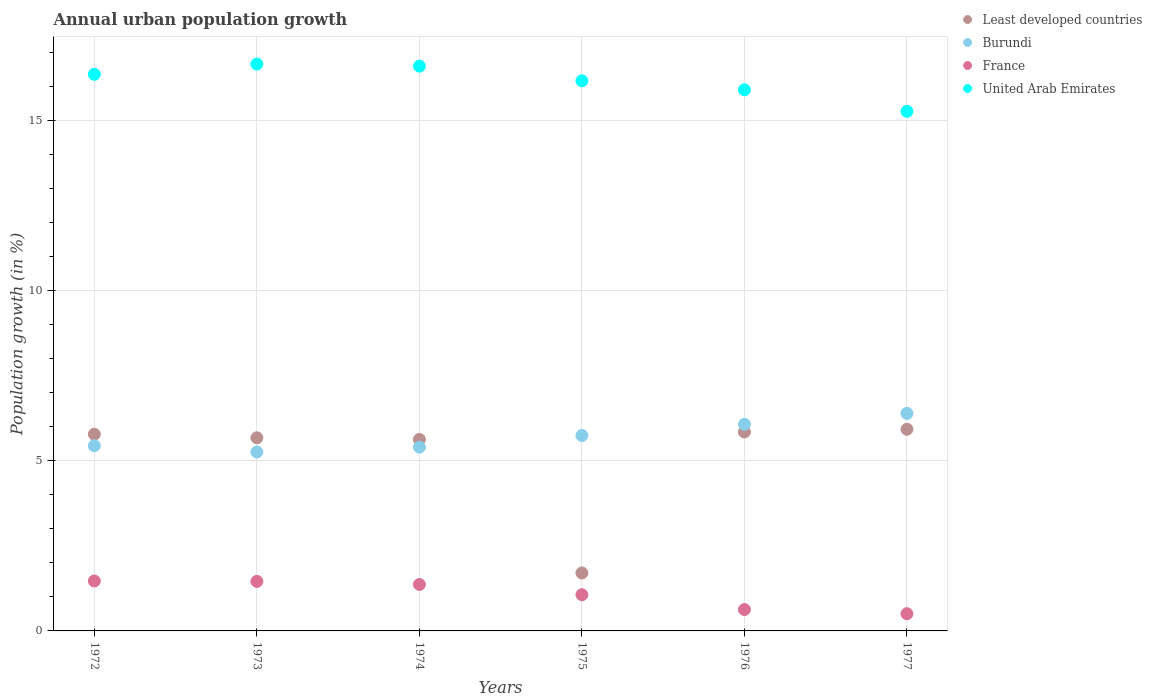What is the percentage of urban population growth in France in 1976?
Offer a very short reply. 0.63. Across all years, what is the maximum percentage of urban population growth in Least developed countries?
Provide a short and direct response. 5.93. Across all years, what is the minimum percentage of urban population growth in United Arab Emirates?
Provide a succinct answer. 15.27. What is the total percentage of urban population growth in United Arab Emirates in the graph?
Offer a very short reply. 96.97. What is the difference between the percentage of urban population growth in United Arab Emirates in 1972 and that in 1974?
Keep it short and to the point. -0.24. What is the difference between the percentage of urban population growth in France in 1975 and the percentage of urban population growth in United Arab Emirates in 1974?
Provide a succinct answer. -15.54. What is the average percentage of urban population growth in Least developed countries per year?
Your answer should be compact. 5.09. In the year 1974, what is the difference between the percentage of urban population growth in Burundi and percentage of urban population growth in France?
Keep it short and to the point. 4.03. In how many years, is the percentage of urban population growth in Least developed countries greater than 10 %?
Ensure brevity in your answer.  0. What is the ratio of the percentage of urban population growth in France in 1973 to that in 1974?
Your answer should be very brief. 1.07. What is the difference between the highest and the second highest percentage of urban population growth in United Arab Emirates?
Keep it short and to the point. 0.06. What is the difference between the highest and the lowest percentage of urban population growth in United Arab Emirates?
Ensure brevity in your answer.  1.39. Is the sum of the percentage of urban population growth in Burundi in 1972 and 1975 greater than the maximum percentage of urban population growth in United Arab Emirates across all years?
Your answer should be very brief. No. Is it the case that in every year, the sum of the percentage of urban population growth in United Arab Emirates and percentage of urban population growth in Burundi  is greater than the sum of percentage of urban population growth in Least developed countries and percentage of urban population growth in France?
Offer a very short reply. Yes. Does the percentage of urban population growth in United Arab Emirates monotonically increase over the years?
Ensure brevity in your answer.  No. Is the percentage of urban population growth in Burundi strictly less than the percentage of urban population growth in United Arab Emirates over the years?
Your answer should be compact. Yes. What is the difference between two consecutive major ticks on the Y-axis?
Make the answer very short. 5. Are the values on the major ticks of Y-axis written in scientific E-notation?
Your answer should be compact. No. Does the graph contain grids?
Ensure brevity in your answer.  Yes. Where does the legend appear in the graph?
Your answer should be compact. Top right. How many legend labels are there?
Offer a very short reply. 4. How are the legend labels stacked?
Make the answer very short. Vertical. What is the title of the graph?
Make the answer very short. Annual urban population growth. What is the label or title of the Y-axis?
Provide a succinct answer. Population growth (in %). What is the Population growth (in %) of Least developed countries in 1972?
Your answer should be compact. 5.78. What is the Population growth (in %) in Burundi in 1972?
Provide a short and direct response. 5.44. What is the Population growth (in %) of France in 1972?
Offer a very short reply. 1.47. What is the Population growth (in %) in United Arab Emirates in 1972?
Your answer should be compact. 16.36. What is the Population growth (in %) in Least developed countries in 1973?
Your answer should be compact. 5.68. What is the Population growth (in %) of Burundi in 1973?
Offer a very short reply. 5.26. What is the Population growth (in %) in France in 1973?
Offer a very short reply. 1.46. What is the Population growth (in %) in United Arab Emirates in 1973?
Your response must be concise. 16.66. What is the Population growth (in %) of Least developed countries in 1974?
Offer a very short reply. 5.63. What is the Population growth (in %) in Burundi in 1974?
Offer a very short reply. 5.4. What is the Population growth (in %) in France in 1974?
Provide a short and direct response. 1.37. What is the Population growth (in %) of United Arab Emirates in 1974?
Your response must be concise. 16.6. What is the Population growth (in %) in Least developed countries in 1975?
Keep it short and to the point. 1.7. What is the Population growth (in %) of Burundi in 1975?
Offer a very short reply. 5.74. What is the Population growth (in %) in France in 1975?
Provide a short and direct response. 1.06. What is the Population growth (in %) of United Arab Emirates in 1975?
Make the answer very short. 16.17. What is the Population growth (in %) of Least developed countries in 1976?
Make the answer very short. 5.85. What is the Population growth (in %) in Burundi in 1976?
Your answer should be compact. 6.07. What is the Population growth (in %) in France in 1976?
Your answer should be very brief. 0.63. What is the Population growth (in %) of United Arab Emirates in 1976?
Offer a very short reply. 15.91. What is the Population growth (in %) of Least developed countries in 1977?
Give a very brief answer. 5.93. What is the Population growth (in %) in Burundi in 1977?
Keep it short and to the point. 6.39. What is the Population growth (in %) in France in 1977?
Your answer should be compact. 0.51. What is the Population growth (in %) in United Arab Emirates in 1977?
Your response must be concise. 15.27. Across all years, what is the maximum Population growth (in %) in Least developed countries?
Make the answer very short. 5.93. Across all years, what is the maximum Population growth (in %) of Burundi?
Offer a very short reply. 6.39. Across all years, what is the maximum Population growth (in %) in France?
Ensure brevity in your answer.  1.47. Across all years, what is the maximum Population growth (in %) of United Arab Emirates?
Provide a short and direct response. 16.66. Across all years, what is the minimum Population growth (in %) in Least developed countries?
Give a very brief answer. 1.7. Across all years, what is the minimum Population growth (in %) of Burundi?
Your response must be concise. 5.26. Across all years, what is the minimum Population growth (in %) in France?
Provide a short and direct response. 0.51. Across all years, what is the minimum Population growth (in %) in United Arab Emirates?
Your response must be concise. 15.27. What is the total Population growth (in %) in Least developed countries in the graph?
Offer a very short reply. 30.57. What is the total Population growth (in %) of Burundi in the graph?
Offer a terse response. 34.31. What is the total Population growth (in %) in France in the graph?
Offer a very short reply. 6.49. What is the total Population growth (in %) of United Arab Emirates in the graph?
Your response must be concise. 96.97. What is the difference between the Population growth (in %) in Least developed countries in 1972 and that in 1973?
Keep it short and to the point. 0.1. What is the difference between the Population growth (in %) in Burundi in 1972 and that in 1973?
Keep it short and to the point. 0.18. What is the difference between the Population growth (in %) of France in 1972 and that in 1973?
Your answer should be very brief. 0.01. What is the difference between the Population growth (in %) in United Arab Emirates in 1972 and that in 1973?
Give a very brief answer. -0.3. What is the difference between the Population growth (in %) of Least developed countries in 1972 and that in 1974?
Your answer should be very brief. 0.15. What is the difference between the Population growth (in %) of Burundi in 1972 and that in 1974?
Offer a very short reply. 0.04. What is the difference between the Population growth (in %) of France in 1972 and that in 1974?
Your answer should be very brief. 0.1. What is the difference between the Population growth (in %) of United Arab Emirates in 1972 and that in 1974?
Your response must be concise. -0.24. What is the difference between the Population growth (in %) of Least developed countries in 1972 and that in 1975?
Your answer should be very brief. 4.08. What is the difference between the Population growth (in %) in Burundi in 1972 and that in 1975?
Keep it short and to the point. -0.3. What is the difference between the Population growth (in %) in France in 1972 and that in 1975?
Offer a very short reply. 0.4. What is the difference between the Population growth (in %) of United Arab Emirates in 1972 and that in 1975?
Your answer should be compact. 0.19. What is the difference between the Population growth (in %) of Least developed countries in 1972 and that in 1976?
Your answer should be compact. -0.07. What is the difference between the Population growth (in %) in Burundi in 1972 and that in 1976?
Make the answer very short. -0.63. What is the difference between the Population growth (in %) of France in 1972 and that in 1976?
Offer a very short reply. 0.84. What is the difference between the Population growth (in %) of United Arab Emirates in 1972 and that in 1976?
Give a very brief answer. 0.46. What is the difference between the Population growth (in %) of Least developed countries in 1972 and that in 1977?
Your answer should be compact. -0.15. What is the difference between the Population growth (in %) in Burundi in 1972 and that in 1977?
Offer a terse response. -0.95. What is the difference between the Population growth (in %) of France in 1972 and that in 1977?
Your answer should be compact. 0.96. What is the difference between the Population growth (in %) in United Arab Emirates in 1972 and that in 1977?
Your answer should be compact. 1.09. What is the difference between the Population growth (in %) in Least developed countries in 1973 and that in 1974?
Provide a succinct answer. 0.05. What is the difference between the Population growth (in %) in Burundi in 1973 and that in 1974?
Ensure brevity in your answer.  -0.14. What is the difference between the Population growth (in %) of France in 1973 and that in 1974?
Make the answer very short. 0.09. What is the difference between the Population growth (in %) in United Arab Emirates in 1973 and that in 1974?
Make the answer very short. 0.06. What is the difference between the Population growth (in %) in Least developed countries in 1973 and that in 1975?
Provide a short and direct response. 3.97. What is the difference between the Population growth (in %) of Burundi in 1973 and that in 1975?
Your response must be concise. -0.48. What is the difference between the Population growth (in %) of France in 1973 and that in 1975?
Provide a short and direct response. 0.39. What is the difference between the Population growth (in %) in United Arab Emirates in 1973 and that in 1975?
Your answer should be compact. 0.49. What is the difference between the Population growth (in %) in Least developed countries in 1973 and that in 1976?
Your answer should be compact. -0.17. What is the difference between the Population growth (in %) of Burundi in 1973 and that in 1976?
Ensure brevity in your answer.  -0.81. What is the difference between the Population growth (in %) in France in 1973 and that in 1976?
Make the answer very short. 0.83. What is the difference between the Population growth (in %) in United Arab Emirates in 1973 and that in 1976?
Give a very brief answer. 0.76. What is the difference between the Population growth (in %) in Least developed countries in 1973 and that in 1977?
Ensure brevity in your answer.  -0.25. What is the difference between the Population growth (in %) of Burundi in 1973 and that in 1977?
Ensure brevity in your answer.  -1.13. What is the difference between the Population growth (in %) in France in 1973 and that in 1977?
Offer a terse response. 0.95. What is the difference between the Population growth (in %) in United Arab Emirates in 1973 and that in 1977?
Offer a very short reply. 1.39. What is the difference between the Population growth (in %) of Least developed countries in 1974 and that in 1975?
Provide a short and direct response. 3.93. What is the difference between the Population growth (in %) of Burundi in 1974 and that in 1975?
Your answer should be very brief. -0.34. What is the difference between the Population growth (in %) in France in 1974 and that in 1975?
Make the answer very short. 0.3. What is the difference between the Population growth (in %) in United Arab Emirates in 1974 and that in 1975?
Give a very brief answer. 0.43. What is the difference between the Population growth (in %) of Least developed countries in 1974 and that in 1976?
Offer a very short reply. -0.22. What is the difference between the Population growth (in %) in Burundi in 1974 and that in 1976?
Your answer should be compact. -0.67. What is the difference between the Population growth (in %) in France in 1974 and that in 1976?
Offer a terse response. 0.74. What is the difference between the Population growth (in %) in United Arab Emirates in 1974 and that in 1976?
Your answer should be compact. 0.69. What is the difference between the Population growth (in %) in Least developed countries in 1974 and that in 1977?
Provide a succinct answer. -0.3. What is the difference between the Population growth (in %) of Burundi in 1974 and that in 1977?
Ensure brevity in your answer.  -0.99. What is the difference between the Population growth (in %) in France in 1974 and that in 1977?
Give a very brief answer. 0.86. What is the difference between the Population growth (in %) in United Arab Emirates in 1974 and that in 1977?
Offer a terse response. 1.33. What is the difference between the Population growth (in %) in Least developed countries in 1975 and that in 1976?
Provide a short and direct response. -4.14. What is the difference between the Population growth (in %) of Burundi in 1975 and that in 1976?
Give a very brief answer. -0.33. What is the difference between the Population growth (in %) of France in 1975 and that in 1976?
Offer a terse response. 0.44. What is the difference between the Population growth (in %) of United Arab Emirates in 1975 and that in 1976?
Your answer should be very brief. 0.26. What is the difference between the Population growth (in %) in Least developed countries in 1975 and that in 1977?
Give a very brief answer. -4.22. What is the difference between the Population growth (in %) in Burundi in 1975 and that in 1977?
Keep it short and to the point. -0.65. What is the difference between the Population growth (in %) of France in 1975 and that in 1977?
Your answer should be compact. 0.56. What is the difference between the Population growth (in %) of United Arab Emirates in 1975 and that in 1977?
Provide a short and direct response. 0.9. What is the difference between the Population growth (in %) in Least developed countries in 1976 and that in 1977?
Your response must be concise. -0.08. What is the difference between the Population growth (in %) in Burundi in 1976 and that in 1977?
Keep it short and to the point. -0.32. What is the difference between the Population growth (in %) in France in 1976 and that in 1977?
Offer a terse response. 0.12. What is the difference between the Population growth (in %) in United Arab Emirates in 1976 and that in 1977?
Provide a short and direct response. 0.63. What is the difference between the Population growth (in %) in Least developed countries in 1972 and the Population growth (in %) in Burundi in 1973?
Offer a very short reply. 0.52. What is the difference between the Population growth (in %) in Least developed countries in 1972 and the Population growth (in %) in France in 1973?
Your response must be concise. 4.33. What is the difference between the Population growth (in %) of Least developed countries in 1972 and the Population growth (in %) of United Arab Emirates in 1973?
Offer a terse response. -10.88. What is the difference between the Population growth (in %) of Burundi in 1972 and the Population growth (in %) of France in 1973?
Offer a very short reply. 3.99. What is the difference between the Population growth (in %) in Burundi in 1972 and the Population growth (in %) in United Arab Emirates in 1973?
Your response must be concise. -11.22. What is the difference between the Population growth (in %) of France in 1972 and the Population growth (in %) of United Arab Emirates in 1973?
Provide a short and direct response. -15.19. What is the difference between the Population growth (in %) in Least developed countries in 1972 and the Population growth (in %) in Burundi in 1974?
Offer a terse response. 0.38. What is the difference between the Population growth (in %) in Least developed countries in 1972 and the Population growth (in %) in France in 1974?
Your response must be concise. 4.41. What is the difference between the Population growth (in %) in Least developed countries in 1972 and the Population growth (in %) in United Arab Emirates in 1974?
Offer a terse response. -10.82. What is the difference between the Population growth (in %) of Burundi in 1972 and the Population growth (in %) of France in 1974?
Your answer should be compact. 4.08. What is the difference between the Population growth (in %) of Burundi in 1972 and the Population growth (in %) of United Arab Emirates in 1974?
Your answer should be very brief. -11.16. What is the difference between the Population growth (in %) in France in 1972 and the Population growth (in %) in United Arab Emirates in 1974?
Your answer should be very brief. -15.13. What is the difference between the Population growth (in %) of Least developed countries in 1972 and the Population growth (in %) of Burundi in 1975?
Ensure brevity in your answer.  0.04. What is the difference between the Population growth (in %) of Least developed countries in 1972 and the Population growth (in %) of France in 1975?
Offer a terse response. 4.72. What is the difference between the Population growth (in %) of Least developed countries in 1972 and the Population growth (in %) of United Arab Emirates in 1975?
Your answer should be very brief. -10.39. What is the difference between the Population growth (in %) in Burundi in 1972 and the Population growth (in %) in France in 1975?
Your response must be concise. 4.38. What is the difference between the Population growth (in %) of Burundi in 1972 and the Population growth (in %) of United Arab Emirates in 1975?
Your answer should be very brief. -10.73. What is the difference between the Population growth (in %) in France in 1972 and the Population growth (in %) in United Arab Emirates in 1975?
Your response must be concise. -14.7. What is the difference between the Population growth (in %) of Least developed countries in 1972 and the Population growth (in %) of Burundi in 1976?
Give a very brief answer. -0.29. What is the difference between the Population growth (in %) in Least developed countries in 1972 and the Population growth (in %) in France in 1976?
Your answer should be very brief. 5.15. What is the difference between the Population growth (in %) in Least developed countries in 1972 and the Population growth (in %) in United Arab Emirates in 1976?
Give a very brief answer. -10.12. What is the difference between the Population growth (in %) of Burundi in 1972 and the Population growth (in %) of France in 1976?
Your answer should be compact. 4.81. What is the difference between the Population growth (in %) of Burundi in 1972 and the Population growth (in %) of United Arab Emirates in 1976?
Ensure brevity in your answer.  -10.46. What is the difference between the Population growth (in %) of France in 1972 and the Population growth (in %) of United Arab Emirates in 1976?
Your answer should be very brief. -14.44. What is the difference between the Population growth (in %) in Least developed countries in 1972 and the Population growth (in %) in Burundi in 1977?
Provide a short and direct response. -0.61. What is the difference between the Population growth (in %) in Least developed countries in 1972 and the Population growth (in %) in France in 1977?
Offer a terse response. 5.28. What is the difference between the Population growth (in %) in Least developed countries in 1972 and the Population growth (in %) in United Arab Emirates in 1977?
Offer a very short reply. -9.49. What is the difference between the Population growth (in %) in Burundi in 1972 and the Population growth (in %) in France in 1977?
Make the answer very short. 4.94. What is the difference between the Population growth (in %) in Burundi in 1972 and the Population growth (in %) in United Arab Emirates in 1977?
Make the answer very short. -9.83. What is the difference between the Population growth (in %) in France in 1972 and the Population growth (in %) in United Arab Emirates in 1977?
Your answer should be compact. -13.8. What is the difference between the Population growth (in %) in Least developed countries in 1973 and the Population growth (in %) in Burundi in 1974?
Ensure brevity in your answer.  0.28. What is the difference between the Population growth (in %) of Least developed countries in 1973 and the Population growth (in %) of France in 1974?
Provide a short and direct response. 4.31. What is the difference between the Population growth (in %) in Least developed countries in 1973 and the Population growth (in %) in United Arab Emirates in 1974?
Your answer should be compact. -10.92. What is the difference between the Population growth (in %) in Burundi in 1973 and the Population growth (in %) in France in 1974?
Your answer should be compact. 3.89. What is the difference between the Population growth (in %) of Burundi in 1973 and the Population growth (in %) of United Arab Emirates in 1974?
Make the answer very short. -11.34. What is the difference between the Population growth (in %) in France in 1973 and the Population growth (in %) in United Arab Emirates in 1974?
Provide a short and direct response. -15.14. What is the difference between the Population growth (in %) of Least developed countries in 1973 and the Population growth (in %) of Burundi in 1975?
Keep it short and to the point. -0.07. What is the difference between the Population growth (in %) in Least developed countries in 1973 and the Population growth (in %) in France in 1975?
Offer a terse response. 4.61. What is the difference between the Population growth (in %) in Least developed countries in 1973 and the Population growth (in %) in United Arab Emirates in 1975?
Ensure brevity in your answer.  -10.49. What is the difference between the Population growth (in %) of Burundi in 1973 and the Population growth (in %) of France in 1975?
Your answer should be very brief. 4.2. What is the difference between the Population growth (in %) in Burundi in 1973 and the Population growth (in %) in United Arab Emirates in 1975?
Ensure brevity in your answer.  -10.91. What is the difference between the Population growth (in %) of France in 1973 and the Population growth (in %) of United Arab Emirates in 1975?
Give a very brief answer. -14.71. What is the difference between the Population growth (in %) in Least developed countries in 1973 and the Population growth (in %) in Burundi in 1976?
Your response must be concise. -0.4. What is the difference between the Population growth (in %) of Least developed countries in 1973 and the Population growth (in %) of France in 1976?
Keep it short and to the point. 5.05. What is the difference between the Population growth (in %) of Least developed countries in 1973 and the Population growth (in %) of United Arab Emirates in 1976?
Provide a short and direct response. -10.23. What is the difference between the Population growth (in %) in Burundi in 1973 and the Population growth (in %) in France in 1976?
Your response must be concise. 4.63. What is the difference between the Population growth (in %) of Burundi in 1973 and the Population growth (in %) of United Arab Emirates in 1976?
Provide a succinct answer. -10.65. What is the difference between the Population growth (in %) in France in 1973 and the Population growth (in %) in United Arab Emirates in 1976?
Offer a very short reply. -14.45. What is the difference between the Population growth (in %) of Least developed countries in 1973 and the Population growth (in %) of Burundi in 1977?
Your answer should be very brief. -0.72. What is the difference between the Population growth (in %) of Least developed countries in 1973 and the Population growth (in %) of France in 1977?
Give a very brief answer. 5.17. What is the difference between the Population growth (in %) in Least developed countries in 1973 and the Population growth (in %) in United Arab Emirates in 1977?
Provide a succinct answer. -9.6. What is the difference between the Population growth (in %) in Burundi in 1973 and the Population growth (in %) in France in 1977?
Your answer should be compact. 4.75. What is the difference between the Population growth (in %) in Burundi in 1973 and the Population growth (in %) in United Arab Emirates in 1977?
Offer a terse response. -10.01. What is the difference between the Population growth (in %) of France in 1973 and the Population growth (in %) of United Arab Emirates in 1977?
Your response must be concise. -13.82. What is the difference between the Population growth (in %) of Least developed countries in 1974 and the Population growth (in %) of Burundi in 1975?
Give a very brief answer. -0.12. What is the difference between the Population growth (in %) in Least developed countries in 1974 and the Population growth (in %) in France in 1975?
Offer a terse response. 4.57. What is the difference between the Population growth (in %) of Least developed countries in 1974 and the Population growth (in %) of United Arab Emirates in 1975?
Keep it short and to the point. -10.54. What is the difference between the Population growth (in %) in Burundi in 1974 and the Population growth (in %) in France in 1975?
Provide a short and direct response. 4.34. What is the difference between the Population growth (in %) of Burundi in 1974 and the Population growth (in %) of United Arab Emirates in 1975?
Ensure brevity in your answer.  -10.77. What is the difference between the Population growth (in %) in France in 1974 and the Population growth (in %) in United Arab Emirates in 1975?
Make the answer very short. -14.8. What is the difference between the Population growth (in %) in Least developed countries in 1974 and the Population growth (in %) in Burundi in 1976?
Keep it short and to the point. -0.44. What is the difference between the Population growth (in %) in Least developed countries in 1974 and the Population growth (in %) in France in 1976?
Offer a very short reply. 5. What is the difference between the Population growth (in %) of Least developed countries in 1974 and the Population growth (in %) of United Arab Emirates in 1976?
Provide a short and direct response. -10.28. What is the difference between the Population growth (in %) in Burundi in 1974 and the Population growth (in %) in France in 1976?
Offer a terse response. 4.77. What is the difference between the Population growth (in %) of Burundi in 1974 and the Population growth (in %) of United Arab Emirates in 1976?
Your answer should be very brief. -10.5. What is the difference between the Population growth (in %) of France in 1974 and the Population growth (in %) of United Arab Emirates in 1976?
Make the answer very short. -14.54. What is the difference between the Population growth (in %) in Least developed countries in 1974 and the Population growth (in %) in Burundi in 1977?
Offer a terse response. -0.76. What is the difference between the Population growth (in %) in Least developed countries in 1974 and the Population growth (in %) in France in 1977?
Provide a succinct answer. 5.12. What is the difference between the Population growth (in %) in Least developed countries in 1974 and the Population growth (in %) in United Arab Emirates in 1977?
Keep it short and to the point. -9.64. What is the difference between the Population growth (in %) in Burundi in 1974 and the Population growth (in %) in France in 1977?
Your answer should be compact. 4.9. What is the difference between the Population growth (in %) in Burundi in 1974 and the Population growth (in %) in United Arab Emirates in 1977?
Keep it short and to the point. -9.87. What is the difference between the Population growth (in %) in France in 1974 and the Population growth (in %) in United Arab Emirates in 1977?
Provide a short and direct response. -13.91. What is the difference between the Population growth (in %) in Least developed countries in 1975 and the Population growth (in %) in Burundi in 1976?
Give a very brief answer. -4.37. What is the difference between the Population growth (in %) of Least developed countries in 1975 and the Population growth (in %) of France in 1976?
Your answer should be compact. 1.08. What is the difference between the Population growth (in %) in Least developed countries in 1975 and the Population growth (in %) in United Arab Emirates in 1976?
Provide a succinct answer. -14.2. What is the difference between the Population growth (in %) of Burundi in 1975 and the Population growth (in %) of France in 1976?
Provide a succinct answer. 5.12. What is the difference between the Population growth (in %) of Burundi in 1975 and the Population growth (in %) of United Arab Emirates in 1976?
Your answer should be compact. -10.16. What is the difference between the Population growth (in %) in France in 1975 and the Population growth (in %) in United Arab Emirates in 1976?
Offer a very short reply. -14.84. What is the difference between the Population growth (in %) in Least developed countries in 1975 and the Population growth (in %) in Burundi in 1977?
Offer a very short reply. -4.69. What is the difference between the Population growth (in %) in Least developed countries in 1975 and the Population growth (in %) in France in 1977?
Your answer should be compact. 1.2. What is the difference between the Population growth (in %) of Least developed countries in 1975 and the Population growth (in %) of United Arab Emirates in 1977?
Your answer should be very brief. -13.57. What is the difference between the Population growth (in %) of Burundi in 1975 and the Population growth (in %) of France in 1977?
Offer a terse response. 5.24. What is the difference between the Population growth (in %) of Burundi in 1975 and the Population growth (in %) of United Arab Emirates in 1977?
Make the answer very short. -9.53. What is the difference between the Population growth (in %) of France in 1975 and the Population growth (in %) of United Arab Emirates in 1977?
Your answer should be compact. -14.21. What is the difference between the Population growth (in %) in Least developed countries in 1976 and the Population growth (in %) in Burundi in 1977?
Keep it short and to the point. -0.55. What is the difference between the Population growth (in %) in Least developed countries in 1976 and the Population growth (in %) in France in 1977?
Your answer should be very brief. 5.34. What is the difference between the Population growth (in %) of Least developed countries in 1976 and the Population growth (in %) of United Arab Emirates in 1977?
Offer a terse response. -9.42. What is the difference between the Population growth (in %) of Burundi in 1976 and the Population growth (in %) of France in 1977?
Provide a succinct answer. 5.57. What is the difference between the Population growth (in %) in Burundi in 1976 and the Population growth (in %) in United Arab Emirates in 1977?
Your response must be concise. -9.2. What is the difference between the Population growth (in %) of France in 1976 and the Population growth (in %) of United Arab Emirates in 1977?
Your response must be concise. -14.64. What is the average Population growth (in %) in Least developed countries per year?
Keep it short and to the point. 5.09. What is the average Population growth (in %) in Burundi per year?
Provide a short and direct response. 5.72. What is the average Population growth (in %) of France per year?
Your response must be concise. 1.08. What is the average Population growth (in %) of United Arab Emirates per year?
Offer a very short reply. 16.16. In the year 1972, what is the difference between the Population growth (in %) in Least developed countries and Population growth (in %) in Burundi?
Keep it short and to the point. 0.34. In the year 1972, what is the difference between the Population growth (in %) of Least developed countries and Population growth (in %) of France?
Provide a short and direct response. 4.31. In the year 1972, what is the difference between the Population growth (in %) of Least developed countries and Population growth (in %) of United Arab Emirates?
Provide a succinct answer. -10.58. In the year 1972, what is the difference between the Population growth (in %) of Burundi and Population growth (in %) of France?
Make the answer very short. 3.97. In the year 1972, what is the difference between the Population growth (in %) in Burundi and Population growth (in %) in United Arab Emirates?
Provide a short and direct response. -10.92. In the year 1972, what is the difference between the Population growth (in %) of France and Population growth (in %) of United Arab Emirates?
Your response must be concise. -14.89. In the year 1973, what is the difference between the Population growth (in %) in Least developed countries and Population growth (in %) in Burundi?
Make the answer very short. 0.42. In the year 1973, what is the difference between the Population growth (in %) in Least developed countries and Population growth (in %) in France?
Provide a succinct answer. 4.22. In the year 1973, what is the difference between the Population growth (in %) of Least developed countries and Population growth (in %) of United Arab Emirates?
Offer a very short reply. -10.99. In the year 1973, what is the difference between the Population growth (in %) in Burundi and Population growth (in %) in France?
Keep it short and to the point. 3.8. In the year 1973, what is the difference between the Population growth (in %) of Burundi and Population growth (in %) of United Arab Emirates?
Offer a terse response. -11.4. In the year 1973, what is the difference between the Population growth (in %) of France and Population growth (in %) of United Arab Emirates?
Ensure brevity in your answer.  -15.21. In the year 1974, what is the difference between the Population growth (in %) in Least developed countries and Population growth (in %) in Burundi?
Your answer should be compact. 0.23. In the year 1974, what is the difference between the Population growth (in %) of Least developed countries and Population growth (in %) of France?
Provide a short and direct response. 4.26. In the year 1974, what is the difference between the Population growth (in %) of Least developed countries and Population growth (in %) of United Arab Emirates?
Your response must be concise. -10.97. In the year 1974, what is the difference between the Population growth (in %) in Burundi and Population growth (in %) in France?
Provide a succinct answer. 4.03. In the year 1974, what is the difference between the Population growth (in %) in Burundi and Population growth (in %) in United Arab Emirates?
Keep it short and to the point. -11.2. In the year 1974, what is the difference between the Population growth (in %) in France and Population growth (in %) in United Arab Emirates?
Make the answer very short. -15.23. In the year 1975, what is the difference between the Population growth (in %) of Least developed countries and Population growth (in %) of Burundi?
Your answer should be very brief. -4.04. In the year 1975, what is the difference between the Population growth (in %) in Least developed countries and Population growth (in %) in France?
Your answer should be compact. 0.64. In the year 1975, what is the difference between the Population growth (in %) of Least developed countries and Population growth (in %) of United Arab Emirates?
Your response must be concise. -14.47. In the year 1975, what is the difference between the Population growth (in %) in Burundi and Population growth (in %) in France?
Keep it short and to the point. 4.68. In the year 1975, what is the difference between the Population growth (in %) in Burundi and Population growth (in %) in United Arab Emirates?
Offer a terse response. -10.42. In the year 1975, what is the difference between the Population growth (in %) of France and Population growth (in %) of United Arab Emirates?
Your response must be concise. -15.11. In the year 1976, what is the difference between the Population growth (in %) in Least developed countries and Population growth (in %) in Burundi?
Provide a succinct answer. -0.23. In the year 1976, what is the difference between the Population growth (in %) of Least developed countries and Population growth (in %) of France?
Ensure brevity in your answer.  5.22. In the year 1976, what is the difference between the Population growth (in %) of Least developed countries and Population growth (in %) of United Arab Emirates?
Provide a short and direct response. -10.06. In the year 1976, what is the difference between the Population growth (in %) of Burundi and Population growth (in %) of France?
Your answer should be very brief. 5.45. In the year 1976, what is the difference between the Population growth (in %) in Burundi and Population growth (in %) in United Arab Emirates?
Your response must be concise. -9.83. In the year 1976, what is the difference between the Population growth (in %) of France and Population growth (in %) of United Arab Emirates?
Offer a terse response. -15.28. In the year 1977, what is the difference between the Population growth (in %) in Least developed countries and Population growth (in %) in Burundi?
Your response must be concise. -0.46. In the year 1977, what is the difference between the Population growth (in %) of Least developed countries and Population growth (in %) of France?
Provide a succinct answer. 5.42. In the year 1977, what is the difference between the Population growth (in %) in Least developed countries and Population growth (in %) in United Arab Emirates?
Your answer should be very brief. -9.34. In the year 1977, what is the difference between the Population growth (in %) of Burundi and Population growth (in %) of France?
Your answer should be very brief. 5.89. In the year 1977, what is the difference between the Population growth (in %) in Burundi and Population growth (in %) in United Arab Emirates?
Give a very brief answer. -8.88. In the year 1977, what is the difference between the Population growth (in %) of France and Population growth (in %) of United Arab Emirates?
Make the answer very short. -14.77. What is the ratio of the Population growth (in %) of Least developed countries in 1972 to that in 1973?
Your response must be concise. 1.02. What is the ratio of the Population growth (in %) in Burundi in 1972 to that in 1973?
Your response must be concise. 1.03. What is the ratio of the Population growth (in %) in France in 1972 to that in 1973?
Offer a terse response. 1.01. What is the ratio of the Population growth (in %) of United Arab Emirates in 1972 to that in 1973?
Provide a short and direct response. 0.98. What is the ratio of the Population growth (in %) of Least developed countries in 1972 to that in 1974?
Give a very brief answer. 1.03. What is the ratio of the Population growth (in %) of France in 1972 to that in 1974?
Your response must be concise. 1.07. What is the ratio of the Population growth (in %) in United Arab Emirates in 1972 to that in 1974?
Your response must be concise. 0.99. What is the ratio of the Population growth (in %) in Least developed countries in 1972 to that in 1975?
Your answer should be compact. 3.39. What is the ratio of the Population growth (in %) of Burundi in 1972 to that in 1975?
Your answer should be compact. 0.95. What is the ratio of the Population growth (in %) of France in 1972 to that in 1975?
Your answer should be compact. 1.38. What is the ratio of the Population growth (in %) in United Arab Emirates in 1972 to that in 1975?
Ensure brevity in your answer.  1.01. What is the ratio of the Population growth (in %) of Burundi in 1972 to that in 1976?
Offer a terse response. 0.9. What is the ratio of the Population growth (in %) in France in 1972 to that in 1976?
Make the answer very short. 2.34. What is the ratio of the Population growth (in %) in United Arab Emirates in 1972 to that in 1976?
Keep it short and to the point. 1.03. What is the ratio of the Population growth (in %) in Least developed countries in 1972 to that in 1977?
Your answer should be very brief. 0.98. What is the ratio of the Population growth (in %) in Burundi in 1972 to that in 1977?
Your response must be concise. 0.85. What is the ratio of the Population growth (in %) in France in 1972 to that in 1977?
Ensure brevity in your answer.  2.91. What is the ratio of the Population growth (in %) of United Arab Emirates in 1972 to that in 1977?
Offer a very short reply. 1.07. What is the ratio of the Population growth (in %) in Least developed countries in 1973 to that in 1974?
Make the answer very short. 1.01. What is the ratio of the Population growth (in %) of Burundi in 1973 to that in 1974?
Give a very brief answer. 0.97. What is the ratio of the Population growth (in %) of France in 1973 to that in 1974?
Your response must be concise. 1.07. What is the ratio of the Population growth (in %) in United Arab Emirates in 1973 to that in 1974?
Ensure brevity in your answer.  1. What is the ratio of the Population growth (in %) of Least developed countries in 1973 to that in 1975?
Your answer should be compact. 3.33. What is the ratio of the Population growth (in %) of Burundi in 1973 to that in 1975?
Ensure brevity in your answer.  0.92. What is the ratio of the Population growth (in %) in France in 1973 to that in 1975?
Offer a very short reply. 1.37. What is the ratio of the Population growth (in %) in United Arab Emirates in 1973 to that in 1975?
Provide a short and direct response. 1.03. What is the ratio of the Population growth (in %) in Least developed countries in 1973 to that in 1976?
Ensure brevity in your answer.  0.97. What is the ratio of the Population growth (in %) in Burundi in 1973 to that in 1976?
Give a very brief answer. 0.87. What is the ratio of the Population growth (in %) of France in 1973 to that in 1976?
Your answer should be very brief. 2.32. What is the ratio of the Population growth (in %) in United Arab Emirates in 1973 to that in 1976?
Give a very brief answer. 1.05. What is the ratio of the Population growth (in %) in Least developed countries in 1973 to that in 1977?
Provide a short and direct response. 0.96. What is the ratio of the Population growth (in %) in Burundi in 1973 to that in 1977?
Your response must be concise. 0.82. What is the ratio of the Population growth (in %) of France in 1973 to that in 1977?
Offer a very short reply. 2.88. What is the ratio of the Population growth (in %) of United Arab Emirates in 1973 to that in 1977?
Your answer should be compact. 1.09. What is the ratio of the Population growth (in %) in Least developed countries in 1974 to that in 1975?
Provide a succinct answer. 3.3. What is the ratio of the Population growth (in %) of Burundi in 1974 to that in 1975?
Your response must be concise. 0.94. What is the ratio of the Population growth (in %) in France in 1974 to that in 1975?
Your answer should be compact. 1.28. What is the ratio of the Population growth (in %) of United Arab Emirates in 1974 to that in 1975?
Provide a short and direct response. 1.03. What is the ratio of the Population growth (in %) in Least developed countries in 1974 to that in 1976?
Your answer should be very brief. 0.96. What is the ratio of the Population growth (in %) of Burundi in 1974 to that in 1976?
Offer a terse response. 0.89. What is the ratio of the Population growth (in %) of France in 1974 to that in 1976?
Keep it short and to the point. 2.17. What is the ratio of the Population growth (in %) in United Arab Emirates in 1974 to that in 1976?
Offer a terse response. 1.04. What is the ratio of the Population growth (in %) in Least developed countries in 1974 to that in 1977?
Give a very brief answer. 0.95. What is the ratio of the Population growth (in %) of Burundi in 1974 to that in 1977?
Keep it short and to the point. 0.84. What is the ratio of the Population growth (in %) of France in 1974 to that in 1977?
Give a very brief answer. 2.7. What is the ratio of the Population growth (in %) in United Arab Emirates in 1974 to that in 1977?
Give a very brief answer. 1.09. What is the ratio of the Population growth (in %) in Least developed countries in 1975 to that in 1976?
Keep it short and to the point. 0.29. What is the ratio of the Population growth (in %) in Burundi in 1975 to that in 1976?
Your answer should be compact. 0.95. What is the ratio of the Population growth (in %) in France in 1975 to that in 1976?
Make the answer very short. 1.69. What is the ratio of the Population growth (in %) of United Arab Emirates in 1975 to that in 1976?
Give a very brief answer. 1.02. What is the ratio of the Population growth (in %) in Least developed countries in 1975 to that in 1977?
Offer a terse response. 0.29. What is the ratio of the Population growth (in %) of Burundi in 1975 to that in 1977?
Make the answer very short. 0.9. What is the ratio of the Population growth (in %) in France in 1975 to that in 1977?
Make the answer very short. 2.11. What is the ratio of the Population growth (in %) of United Arab Emirates in 1975 to that in 1977?
Keep it short and to the point. 1.06. What is the ratio of the Population growth (in %) in Least developed countries in 1976 to that in 1977?
Keep it short and to the point. 0.99. What is the ratio of the Population growth (in %) in Burundi in 1976 to that in 1977?
Offer a very short reply. 0.95. What is the ratio of the Population growth (in %) of France in 1976 to that in 1977?
Provide a succinct answer. 1.24. What is the ratio of the Population growth (in %) of United Arab Emirates in 1976 to that in 1977?
Keep it short and to the point. 1.04. What is the difference between the highest and the second highest Population growth (in %) of Least developed countries?
Make the answer very short. 0.08. What is the difference between the highest and the second highest Population growth (in %) in Burundi?
Provide a short and direct response. 0.32. What is the difference between the highest and the second highest Population growth (in %) in France?
Give a very brief answer. 0.01. What is the difference between the highest and the second highest Population growth (in %) of United Arab Emirates?
Provide a short and direct response. 0.06. What is the difference between the highest and the lowest Population growth (in %) of Least developed countries?
Offer a very short reply. 4.22. What is the difference between the highest and the lowest Population growth (in %) in Burundi?
Your answer should be compact. 1.13. What is the difference between the highest and the lowest Population growth (in %) in France?
Keep it short and to the point. 0.96. What is the difference between the highest and the lowest Population growth (in %) of United Arab Emirates?
Offer a very short reply. 1.39. 